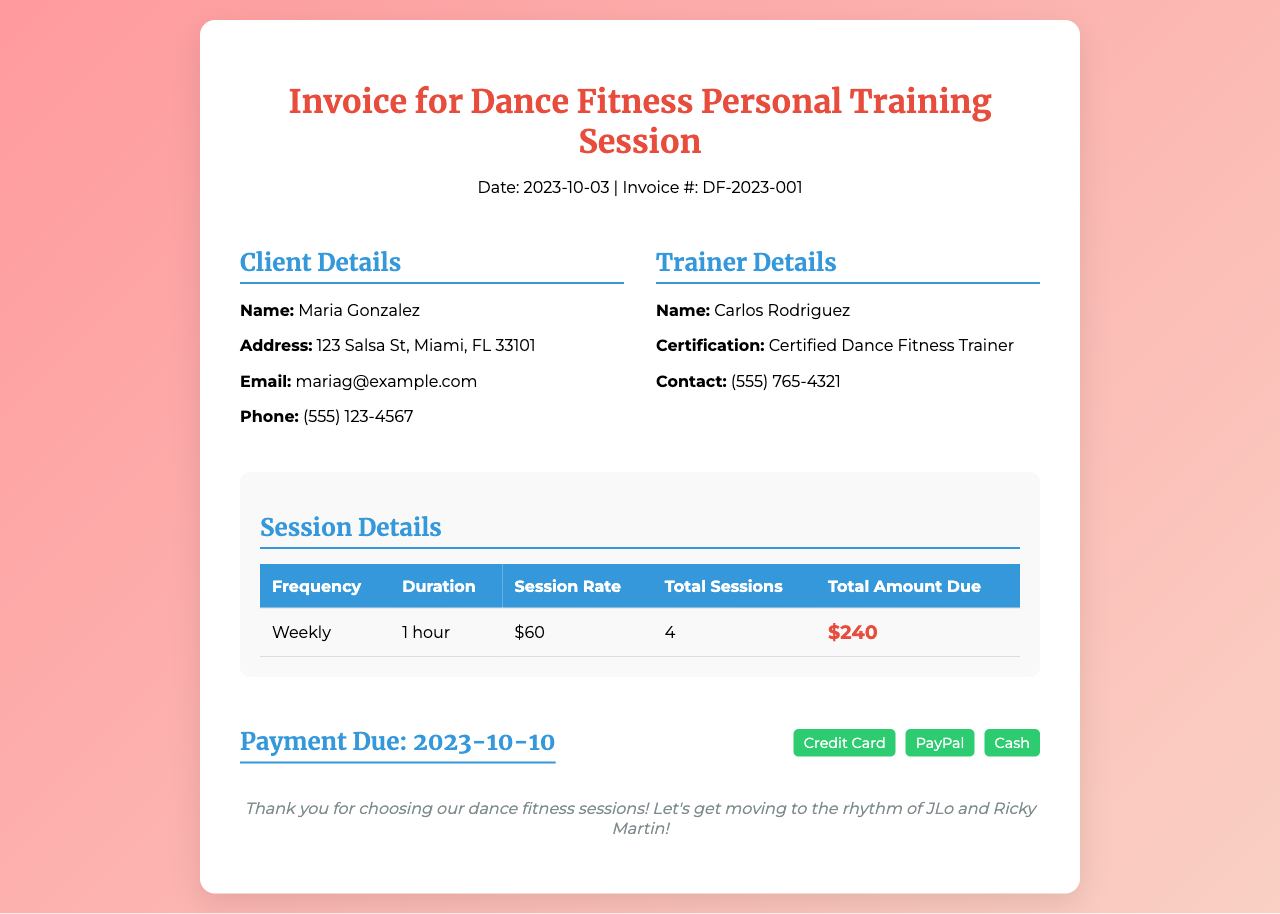What is the date of the invoice? The date of the invoice is clearly mentioned in the header section of the document.
Answer: 2023-10-03 Who is the client? The client's information is provided under the client details section of the invoice.
Answer: Maria Gonzalez What is the total amount due? The total amount due is found in the session details table.
Answer: $240 How many total sessions are included? The total number of sessions is listed in the session details table.
Answer: 4 What is the session rate? The session rate is part of the table outlining the session details.
Answer: $60 What payment methods are accepted? The payment methods are listed in the payment info section of the invoice.
Answer: Credit Card, PayPal, Cash What is the payment due date? The payment due date is specified in the payment info section.
Answer: 2023-10-10 What is the trainer's name? The trainer's name is mentioned in the trainer details section of the invoice.
Answer: Carlos Rodriguez 